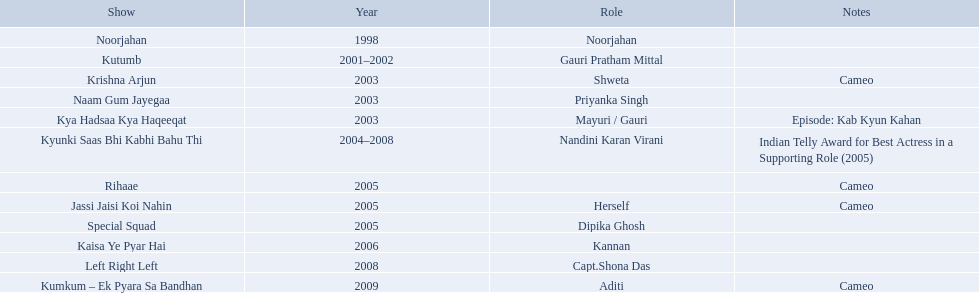What are all of the shows? Noorjahan, Kutumb, Krishna Arjun, Naam Gum Jayegaa, Kya Hadsaa Kya Haqeeqat, Kyunki Saas Bhi Kabhi Bahu Thi, Rihaae, Jassi Jaisi Koi Nahin, Special Squad, Kaisa Ye Pyar Hai, Left Right Left, Kumkum – Ek Pyara Sa Bandhan. When were they in production? 1998, 2001–2002, 2003, 2003, 2003, 2004–2008, 2005, 2005, 2005, 2006, 2008, 2009. And which show was he on for the longest time? Kyunki Saas Bhi Kabhi Bahu Thi. 